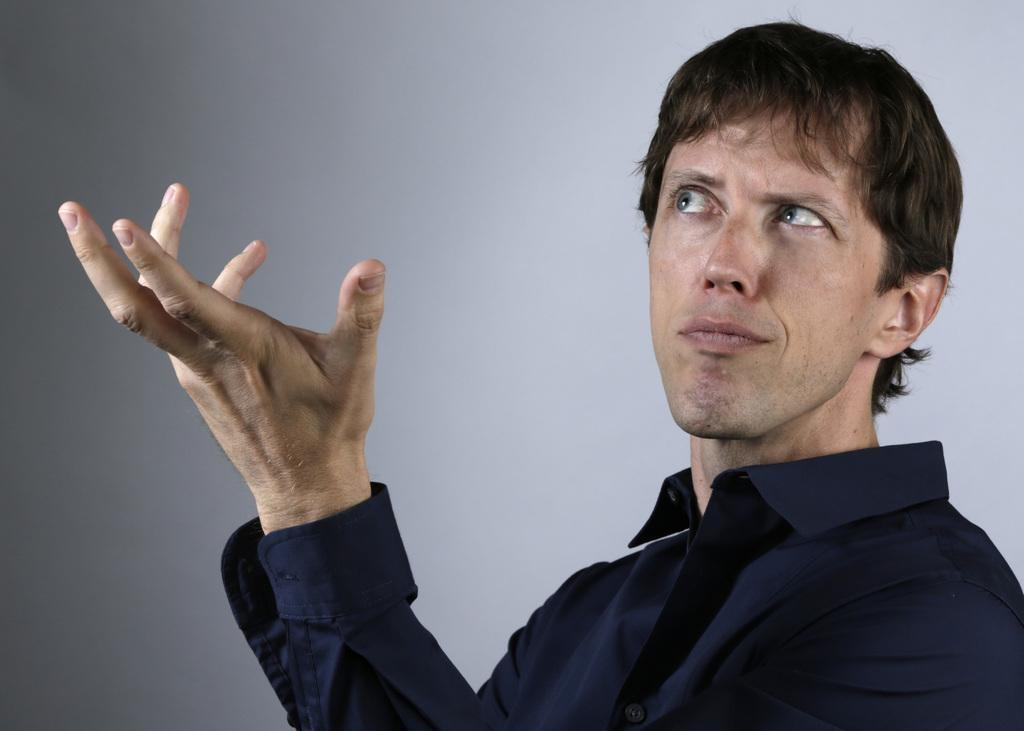What is the main subject in the foreground of the image? There is a person in the foreground of the image. What is the person wearing in the image? The person is wearing a blue shirt. What can be seen in the background of the image? There is a wall in the background of the image. What type of metal is the wrench made of in the image? There is no wrench present in the image. How many sponges can be seen on the person's shirt in the image? There are no sponges visible on the person's shirt in the image. 